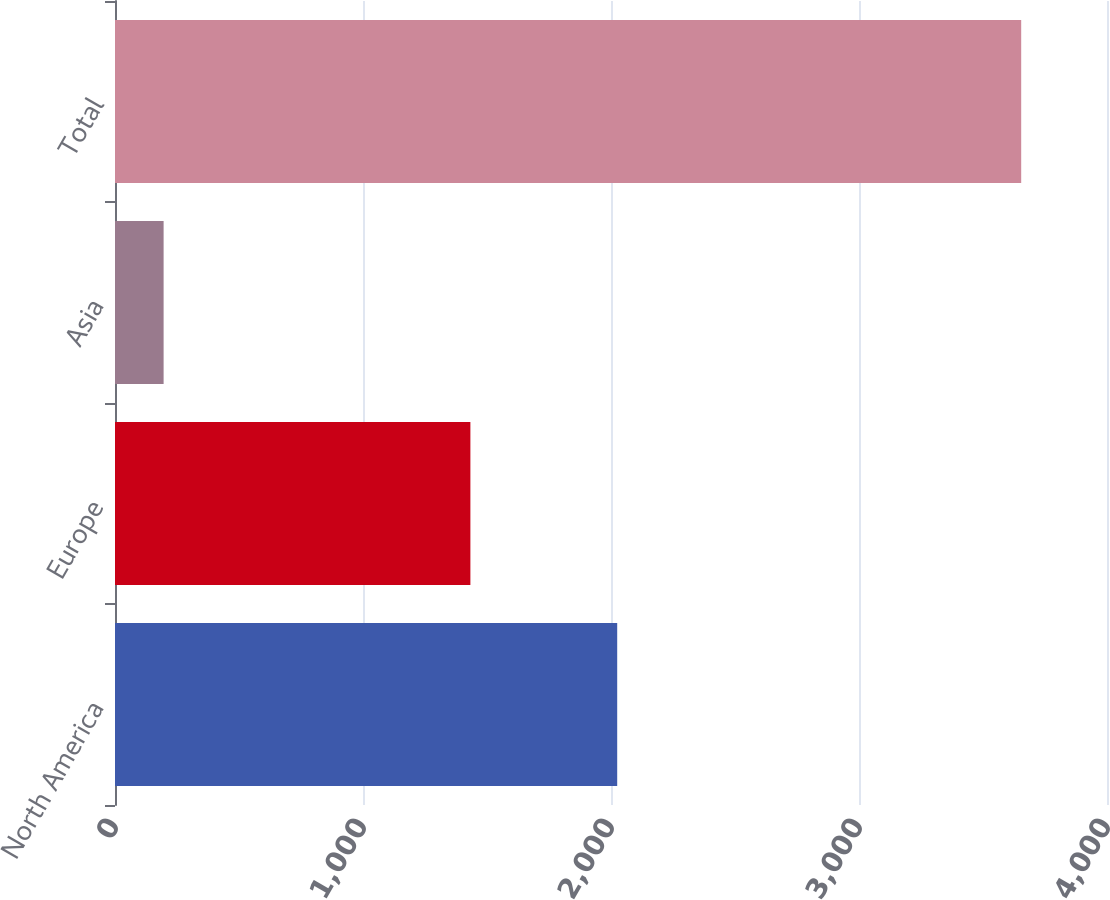Convert chart to OTSL. <chart><loc_0><loc_0><loc_500><loc_500><bar_chart><fcel>North America<fcel>Europe<fcel>Asia<fcel>Total<nl><fcel>2025<fcel>1433<fcel>196<fcel>3654<nl></chart> 